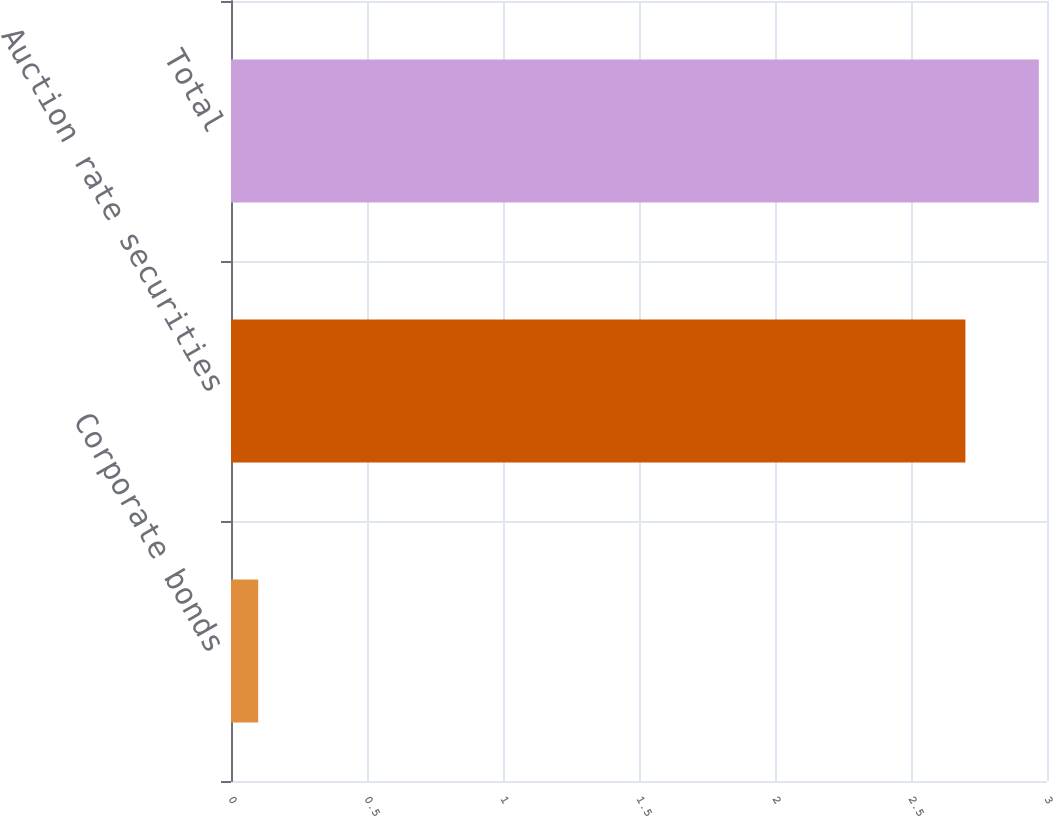Convert chart. <chart><loc_0><loc_0><loc_500><loc_500><bar_chart><fcel>Corporate bonds<fcel>Auction rate securities<fcel>Total<nl><fcel>0.1<fcel>2.7<fcel>2.97<nl></chart> 